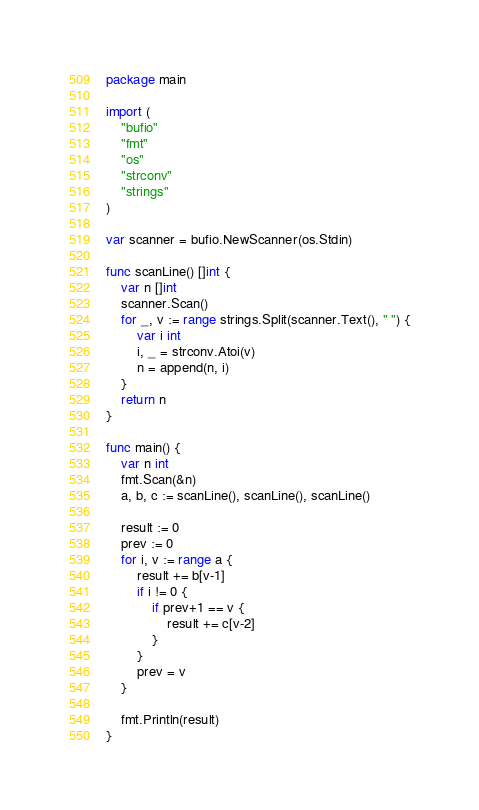Convert code to text. <code><loc_0><loc_0><loc_500><loc_500><_Go_>package main

import (
	"bufio"
	"fmt"
	"os"
	"strconv"
	"strings"
)

var scanner = bufio.NewScanner(os.Stdin)

func scanLine() []int {
	var n []int
	scanner.Scan()
	for _, v := range strings.Split(scanner.Text(), " ") {
		var i int
		i, _ = strconv.Atoi(v)
		n = append(n, i)
	}
	return n
}

func main() {
	var n int
	fmt.Scan(&n)
	a, b, c := scanLine(), scanLine(), scanLine()

	result := 0
	prev := 0
	for i, v := range a {
		result += b[v-1]
		if i != 0 {
			if prev+1 == v {
				result += c[v-2]
			}
		}
		prev = v
	}

	fmt.Println(result)
}
</code> 